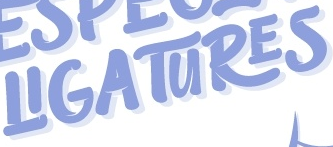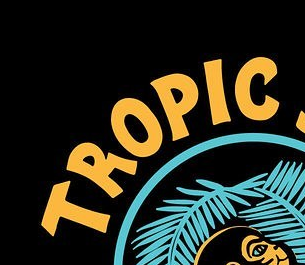Read the text from these images in sequence, separated by a semicolon. LIGATURES; TROPLC 